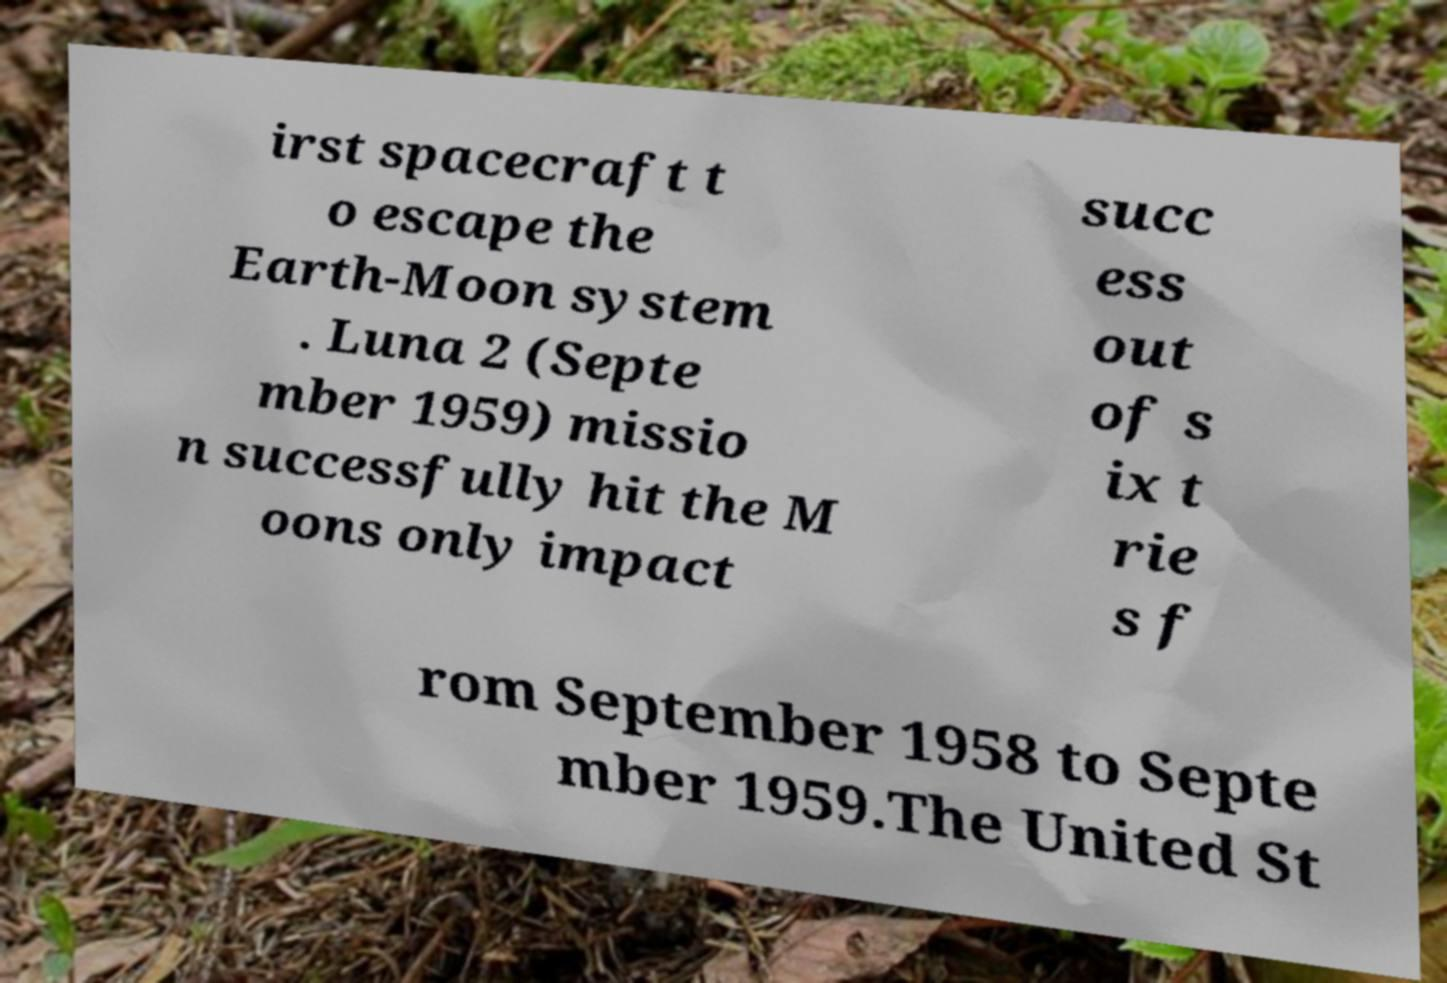I need the written content from this picture converted into text. Can you do that? irst spacecraft t o escape the Earth-Moon system . Luna 2 (Septe mber 1959) missio n successfully hit the M oons only impact succ ess out of s ix t rie s f rom September 1958 to Septe mber 1959.The United St 